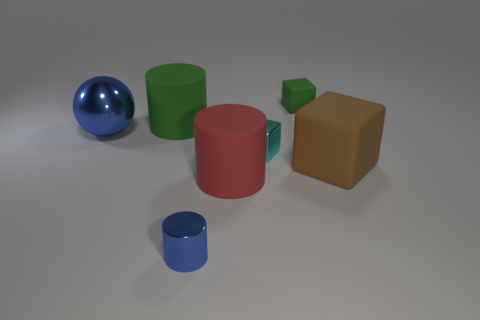There is a shiny sphere that is the same size as the red cylinder; what color is it?
Provide a short and direct response. Blue. There is a rubber cube in front of the big green rubber thing; does it have the same color as the shiny sphere?
Provide a succinct answer. No. Are there any tiny blue objects that have the same material as the red thing?
Your answer should be very brief. No. The big object that is the same color as the small metallic cylinder is what shape?
Offer a very short reply. Sphere. Are there fewer large cubes behind the large brown cube than small blue metallic cylinders?
Provide a succinct answer. Yes. Is the size of the rubber block that is in front of the green rubber cube the same as the small green matte cube?
Provide a short and direct response. No. What number of other brown things have the same shape as the small rubber object?
Offer a very short reply. 1. There is a green thing that is the same material as the green cube; what size is it?
Offer a terse response. Large. Is the number of tiny cyan blocks on the left side of the large blue sphere the same as the number of tiny purple balls?
Offer a very short reply. Yes. Does the ball have the same color as the big cube?
Give a very brief answer. No. 